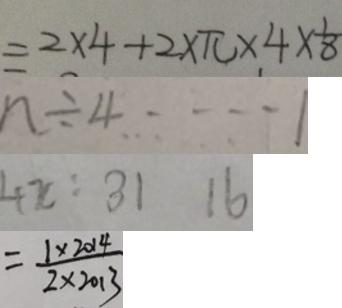<formula> <loc_0><loc_0><loc_500><loc_500>= 2 \times 4 + 2 \times \pi + 4 \times \frac { 1 } { 8 } 
 n \div 4 \cdots 1 
 4 x : 3 1 1 6 
 = \frac { 1 \times 2 0 1 4 } { 2 \times 2 0 1 3 }</formula> 